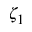Convert formula to latex. <formula><loc_0><loc_0><loc_500><loc_500>\zeta _ { 1 }</formula> 